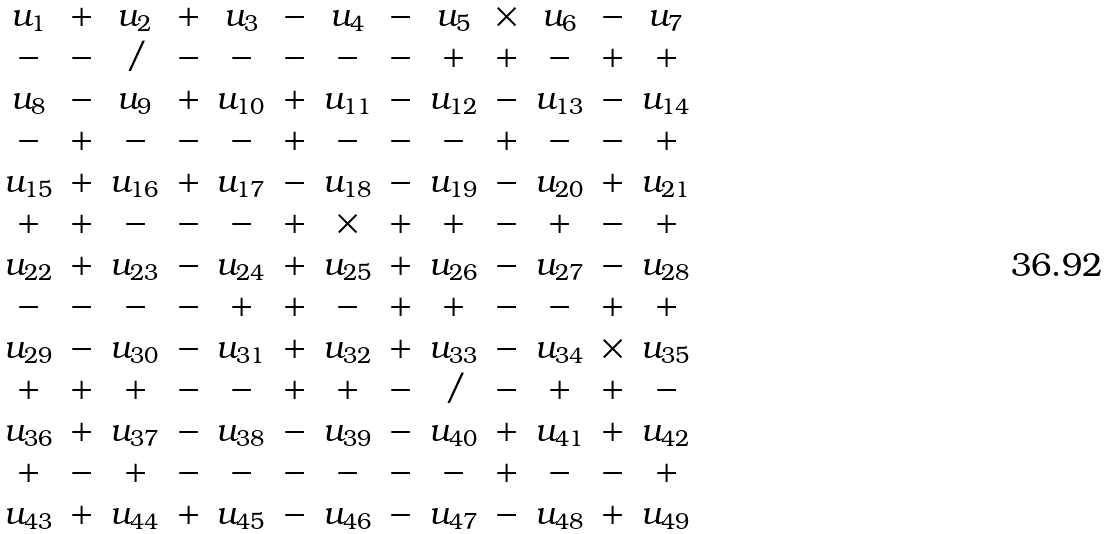Convert formula to latex. <formula><loc_0><loc_0><loc_500><loc_500>\begin{array} { c c c c c c c c c c c c c } u _ { 1 } & + & u _ { 2 } & + & u _ { 3 } & - & u _ { 4 } & - & u _ { 5 } & \times & u _ { 6 } & - & u _ { 7 } \\ - & - & / & - & - & - & - & - & + & + & - & + & + \\ u _ { 8 } & - & u _ { 9 } & + & u _ { 1 0 } & + & u _ { 1 1 } & - & u _ { 1 2 } & - & u _ { 1 3 } & - & u _ { 1 4 } \\ - & + & - & - & - & + & - & - & - & + & - & - & + \\ u _ { 1 5 } & + & u _ { 1 6 } & + & u _ { 1 7 } & - & u _ { 1 8 } & - & u _ { 1 9 } & - & u _ { 2 0 } & + & u _ { 2 1 } \\ + & + & - & - & - & + & \times & + & + & - & + & - & + \\ u _ { 2 2 } & + & u _ { 2 3 } & - & u _ { 2 4 } & + & u _ { 2 5 } & + & u _ { 2 6 } & - & u _ { 2 7 } & - & u _ { 2 8 } \\ - & - & - & - & + & + & - & + & + & - & - & + & + \\ u _ { 2 9 } & - & u _ { 3 0 } & - & u _ { 3 1 } & + & u _ { 3 2 } & + & u _ { 3 3 } & - & u _ { 3 4 } & \times & u _ { 3 5 } \\ + & + & + & - & - & + & + & - & / & - & + & + & - \\ u _ { 3 6 } & + & u _ { 3 7 } & - & u _ { 3 8 } & - & u _ { 3 9 } & - & u _ { 4 0 } & + & u _ { 4 1 } & + & u _ { 4 2 } \\ + & - & + & - & - & - & - & - & - & + & - & - & + \\ u _ { 4 3 } & + & u _ { 4 4 } & + & u _ { 4 5 } & - & u _ { 4 6 } & - & u _ { 4 7 } & - & u _ { 4 8 } & + & u _ { 4 9 } \end{array}</formula> 